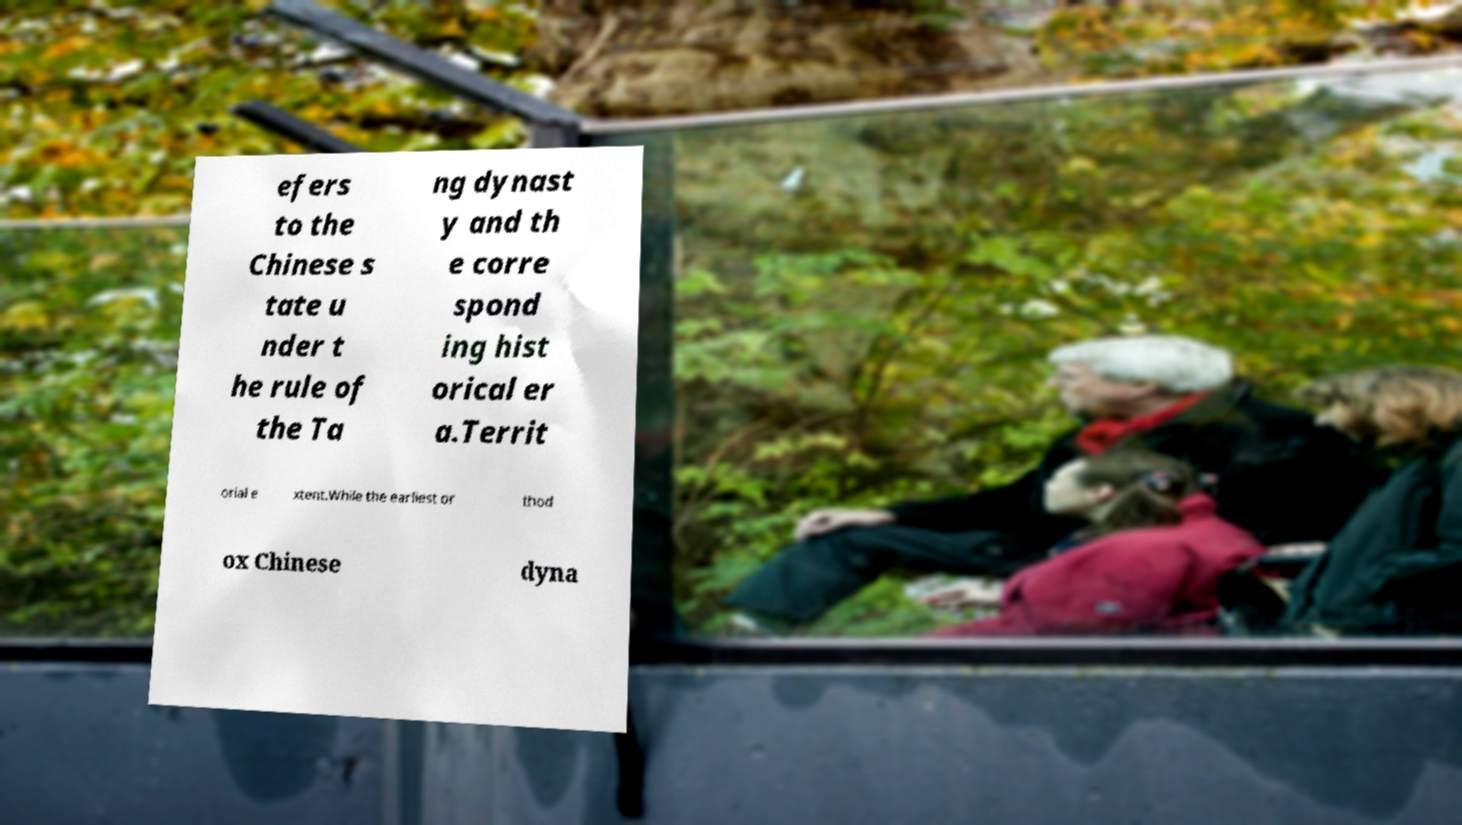Could you assist in decoding the text presented in this image and type it out clearly? efers to the Chinese s tate u nder t he rule of the Ta ng dynast y and th e corre spond ing hist orical er a.Territ orial e xtent.While the earliest or thod ox Chinese dyna 